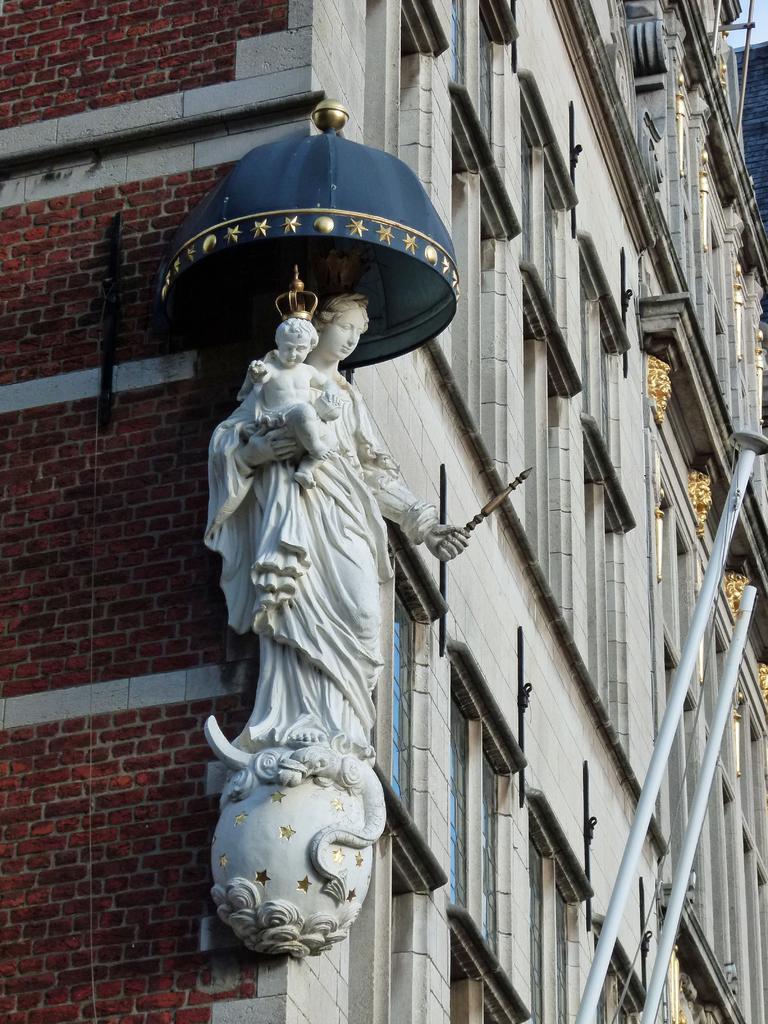How would you summarize this image in a sentence or two? In this image I see the sculpture over here which is of a woman and a baby and the sculpture is of white in color and I see the building and I see the white rods over here and I see number of windows. 